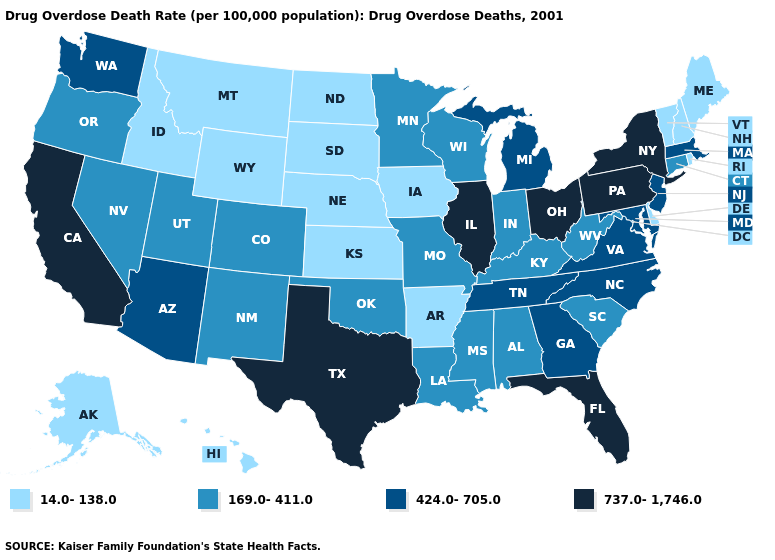What is the value of Kansas?
Give a very brief answer. 14.0-138.0. Which states hav the highest value in the Northeast?
Write a very short answer. New York, Pennsylvania. Name the states that have a value in the range 169.0-411.0?
Give a very brief answer. Alabama, Colorado, Connecticut, Indiana, Kentucky, Louisiana, Minnesota, Mississippi, Missouri, Nevada, New Mexico, Oklahoma, Oregon, South Carolina, Utah, West Virginia, Wisconsin. Does Louisiana have a higher value than New Hampshire?
Write a very short answer. Yes. Name the states that have a value in the range 424.0-705.0?
Short answer required. Arizona, Georgia, Maryland, Massachusetts, Michigan, New Jersey, North Carolina, Tennessee, Virginia, Washington. Does Maryland have the highest value in the USA?
Give a very brief answer. No. Name the states that have a value in the range 737.0-1,746.0?
Quick response, please. California, Florida, Illinois, New York, Ohio, Pennsylvania, Texas. Name the states that have a value in the range 424.0-705.0?
Quick response, please. Arizona, Georgia, Maryland, Massachusetts, Michigan, New Jersey, North Carolina, Tennessee, Virginia, Washington. Among the states that border Missouri , which have the lowest value?
Keep it brief. Arkansas, Iowa, Kansas, Nebraska. Does Florida have the lowest value in the USA?
Short answer required. No. How many symbols are there in the legend?
Give a very brief answer. 4. Which states have the lowest value in the USA?
Give a very brief answer. Alaska, Arkansas, Delaware, Hawaii, Idaho, Iowa, Kansas, Maine, Montana, Nebraska, New Hampshire, North Dakota, Rhode Island, South Dakota, Vermont, Wyoming. Does the first symbol in the legend represent the smallest category?
Give a very brief answer. Yes. Is the legend a continuous bar?
Be succinct. No. Name the states that have a value in the range 169.0-411.0?
Write a very short answer. Alabama, Colorado, Connecticut, Indiana, Kentucky, Louisiana, Minnesota, Mississippi, Missouri, Nevada, New Mexico, Oklahoma, Oregon, South Carolina, Utah, West Virginia, Wisconsin. 